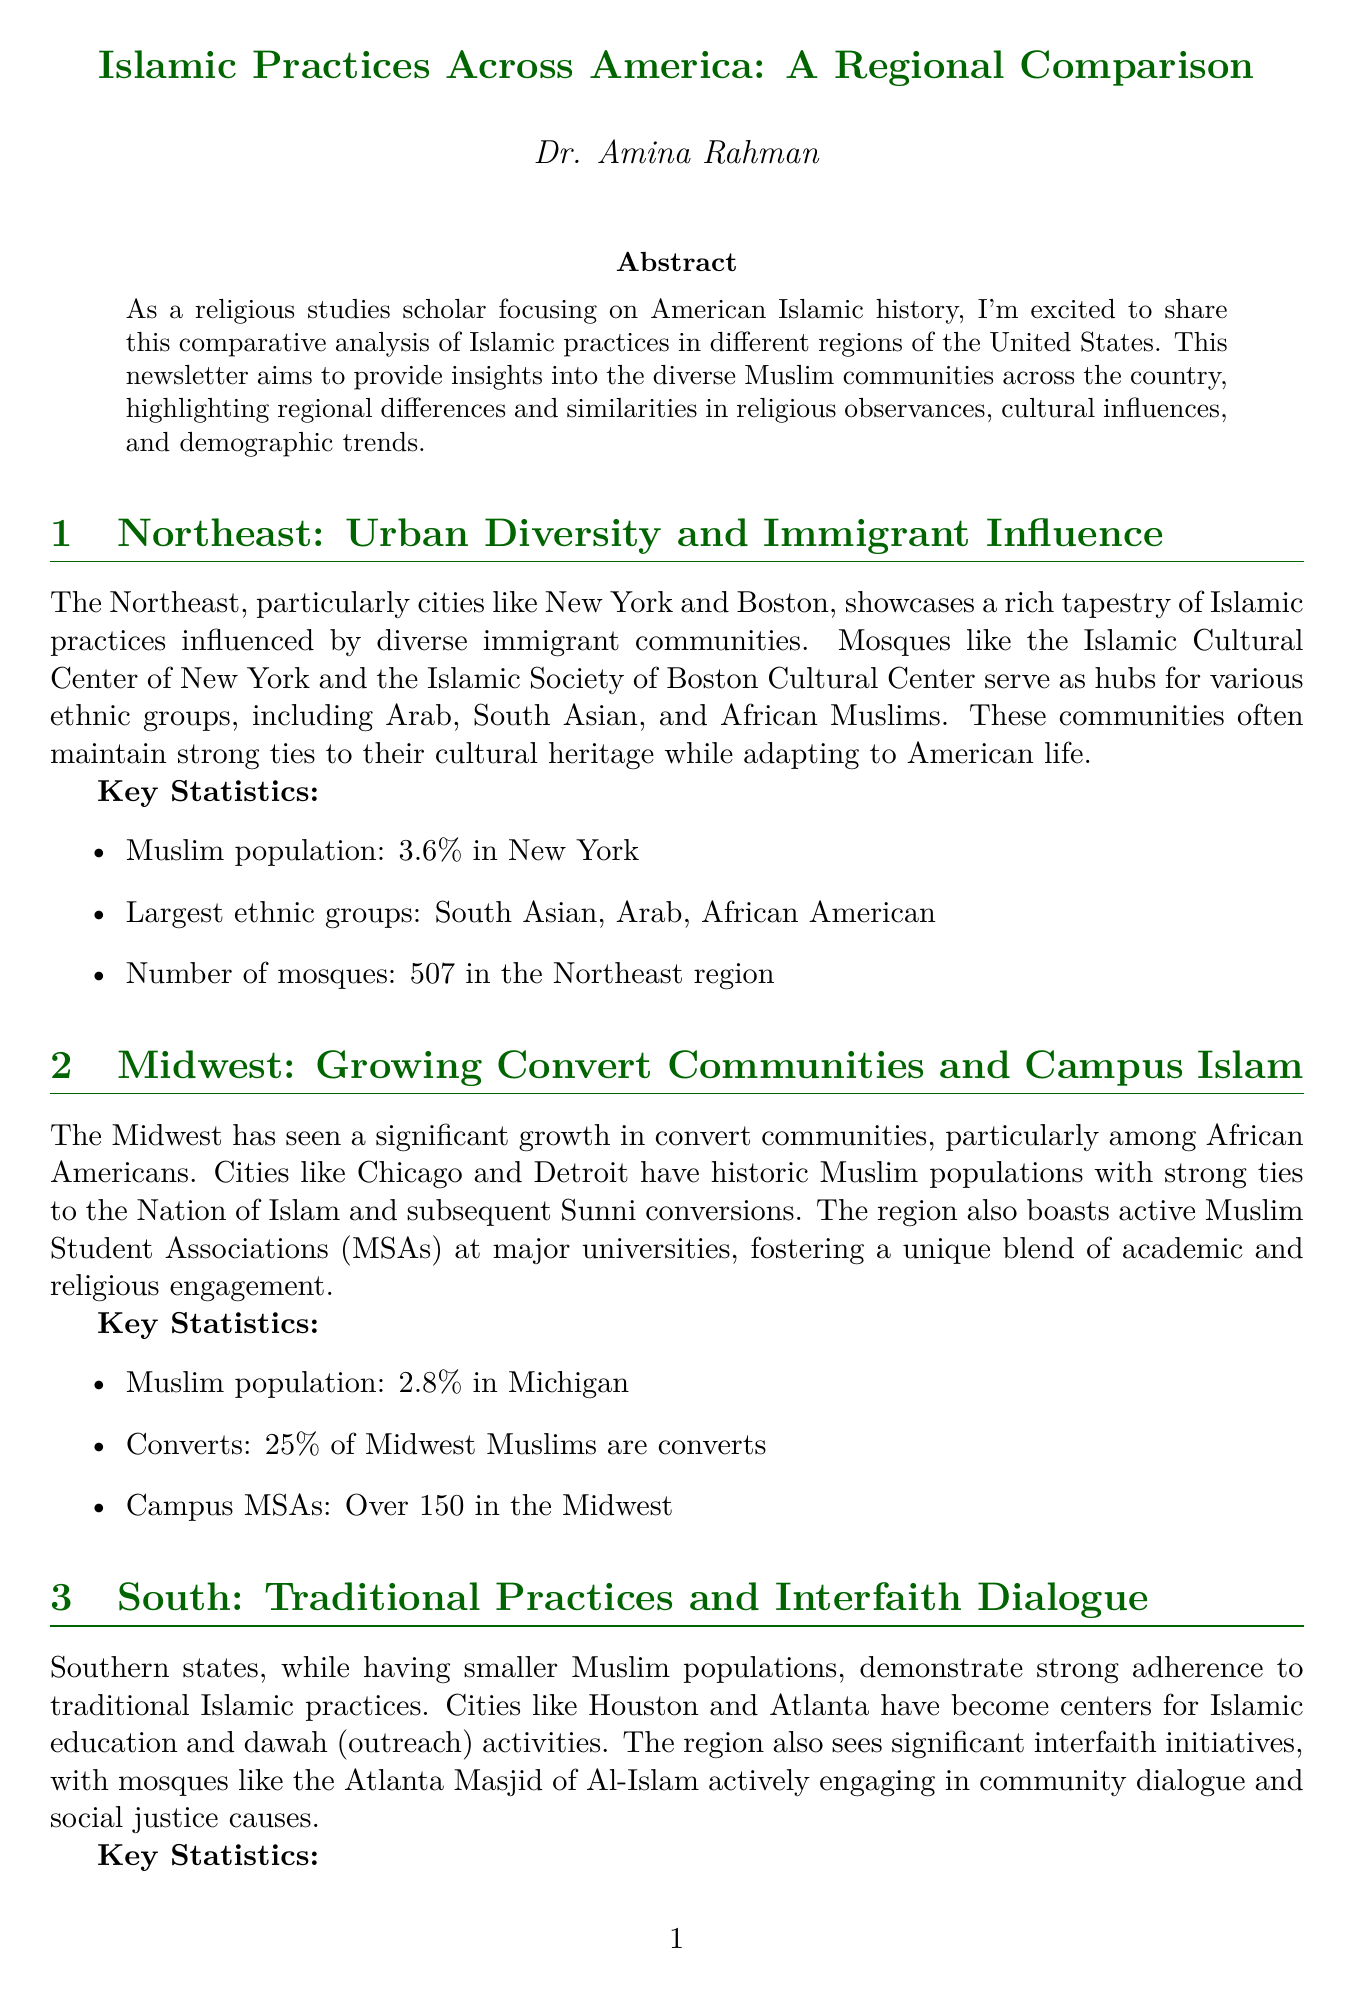What is the title of the newsletter? The title of the newsletter is provided at the beginning of the document.
Answer: Islamic Practices Across America: A Regional Comparison What percentage of Muslims are converts in the Midwest? The percentage of converts is explicitly listed in the Midwest section.
Answer: 25% How many mosques are in the Northeast region? The number of mosques is a key statistic mentioned for the Northeast section.
Answer: 507 What is the Muslim population percentage in Texas? The document specifies the Muslim population percentage in the Southern region, including Texas.
Answer: 1.5% Which city is highlighted as a center for traditional Islamic practices in the South? The city is mentioned within the context of Southern regions in the document.
Answer: Houston What is the focus of the organizations on the West Coast? The West Coast section discusses the nature of practices and organizations in California.
Answer: Progressive interpretations Which state has a 3.6% Muslim population? The document provides specific statistics about states and their Muslim populations.
Answer: New York What type of chart illustrates mosque attendance by region? The document specifies the type of visualization used for mosque attendance rates.
Answer: Bar Chart What is the name of the author of the newsletter? The author is introduced in the About the Author section of the document.
Answer: Dr. Amina Rahman 